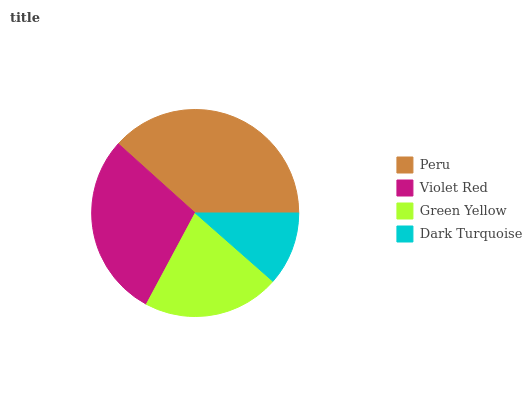Is Dark Turquoise the minimum?
Answer yes or no. Yes. Is Peru the maximum?
Answer yes or no. Yes. Is Violet Red the minimum?
Answer yes or no. No. Is Violet Red the maximum?
Answer yes or no. No. Is Peru greater than Violet Red?
Answer yes or no. Yes. Is Violet Red less than Peru?
Answer yes or no. Yes. Is Violet Red greater than Peru?
Answer yes or no. No. Is Peru less than Violet Red?
Answer yes or no. No. Is Violet Red the high median?
Answer yes or no. Yes. Is Green Yellow the low median?
Answer yes or no. Yes. Is Dark Turquoise the high median?
Answer yes or no. No. Is Dark Turquoise the low median?
Answer yes or no. No. 